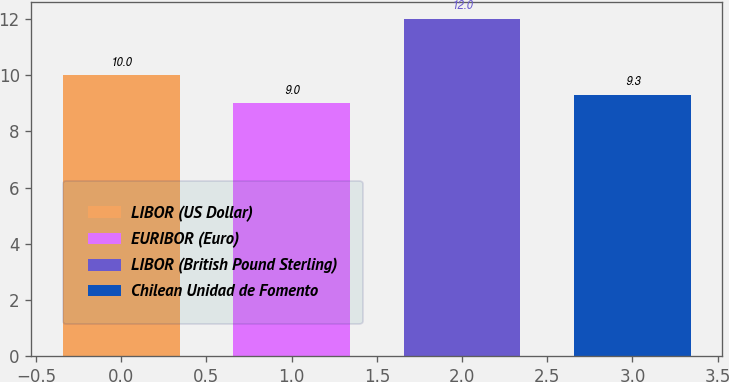<chart> <loc_0><loc_0><loc_500><loc_500><bar_chart><fcel>LIBOR (US Dollar)<fcel>EURIBOR (Euro)<fcel>LIBOR (British Pound Sterling)<fcel>Chilean Unidad de Fomento<nl><fcel>10<fcel>9<fcel>12<fcel>9.3<nl></chart> 